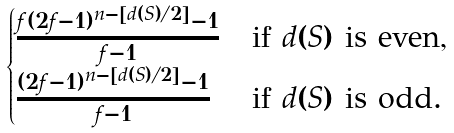Convert formula to latex. <formula><loc_0><loc_0><loc_500><loc_500>\begin{cases} \frac { f ( 2 f - 1 ) ^ { n - [ d ( S ) / 2 ] } - 1 } { f - 1 } & \text {if $d(S)$ is even,} \\ \frac { ( 2 f - 1 ) ^ { n - [ d ( S ) / 2 ] } - 1 } { f - 1 } & \text {if $d(S)$ is odd.} \end{cases}</formula> 